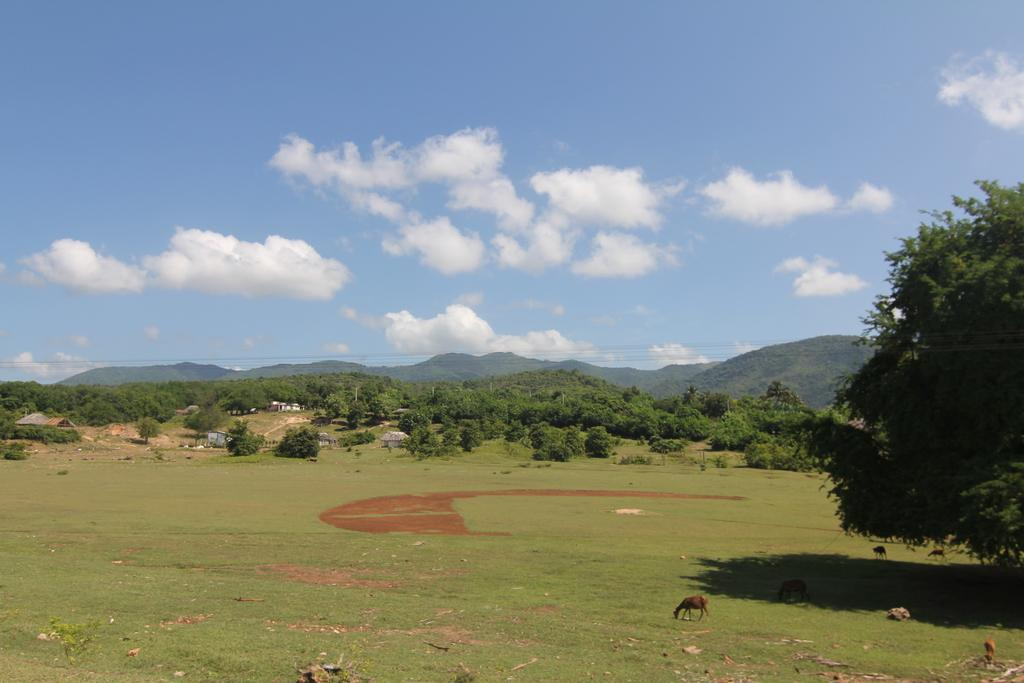What type of landscape is depicted in the image? There is a meadow in the image. What can be seen on the meadow? There are animals on the meadow. Can you describe the right side of the image? There is a tree on the right side of the image. What is visible in the background of the image? There are trees, houses, hills, and the sky visible in the background of the image. What is the condition of the sky in the image? Clouds are present in the sky. How many toes can be seen on the animals in the image? There is no way to determine the number of toes on the animals in the image, as they are not visible or identifiable. 